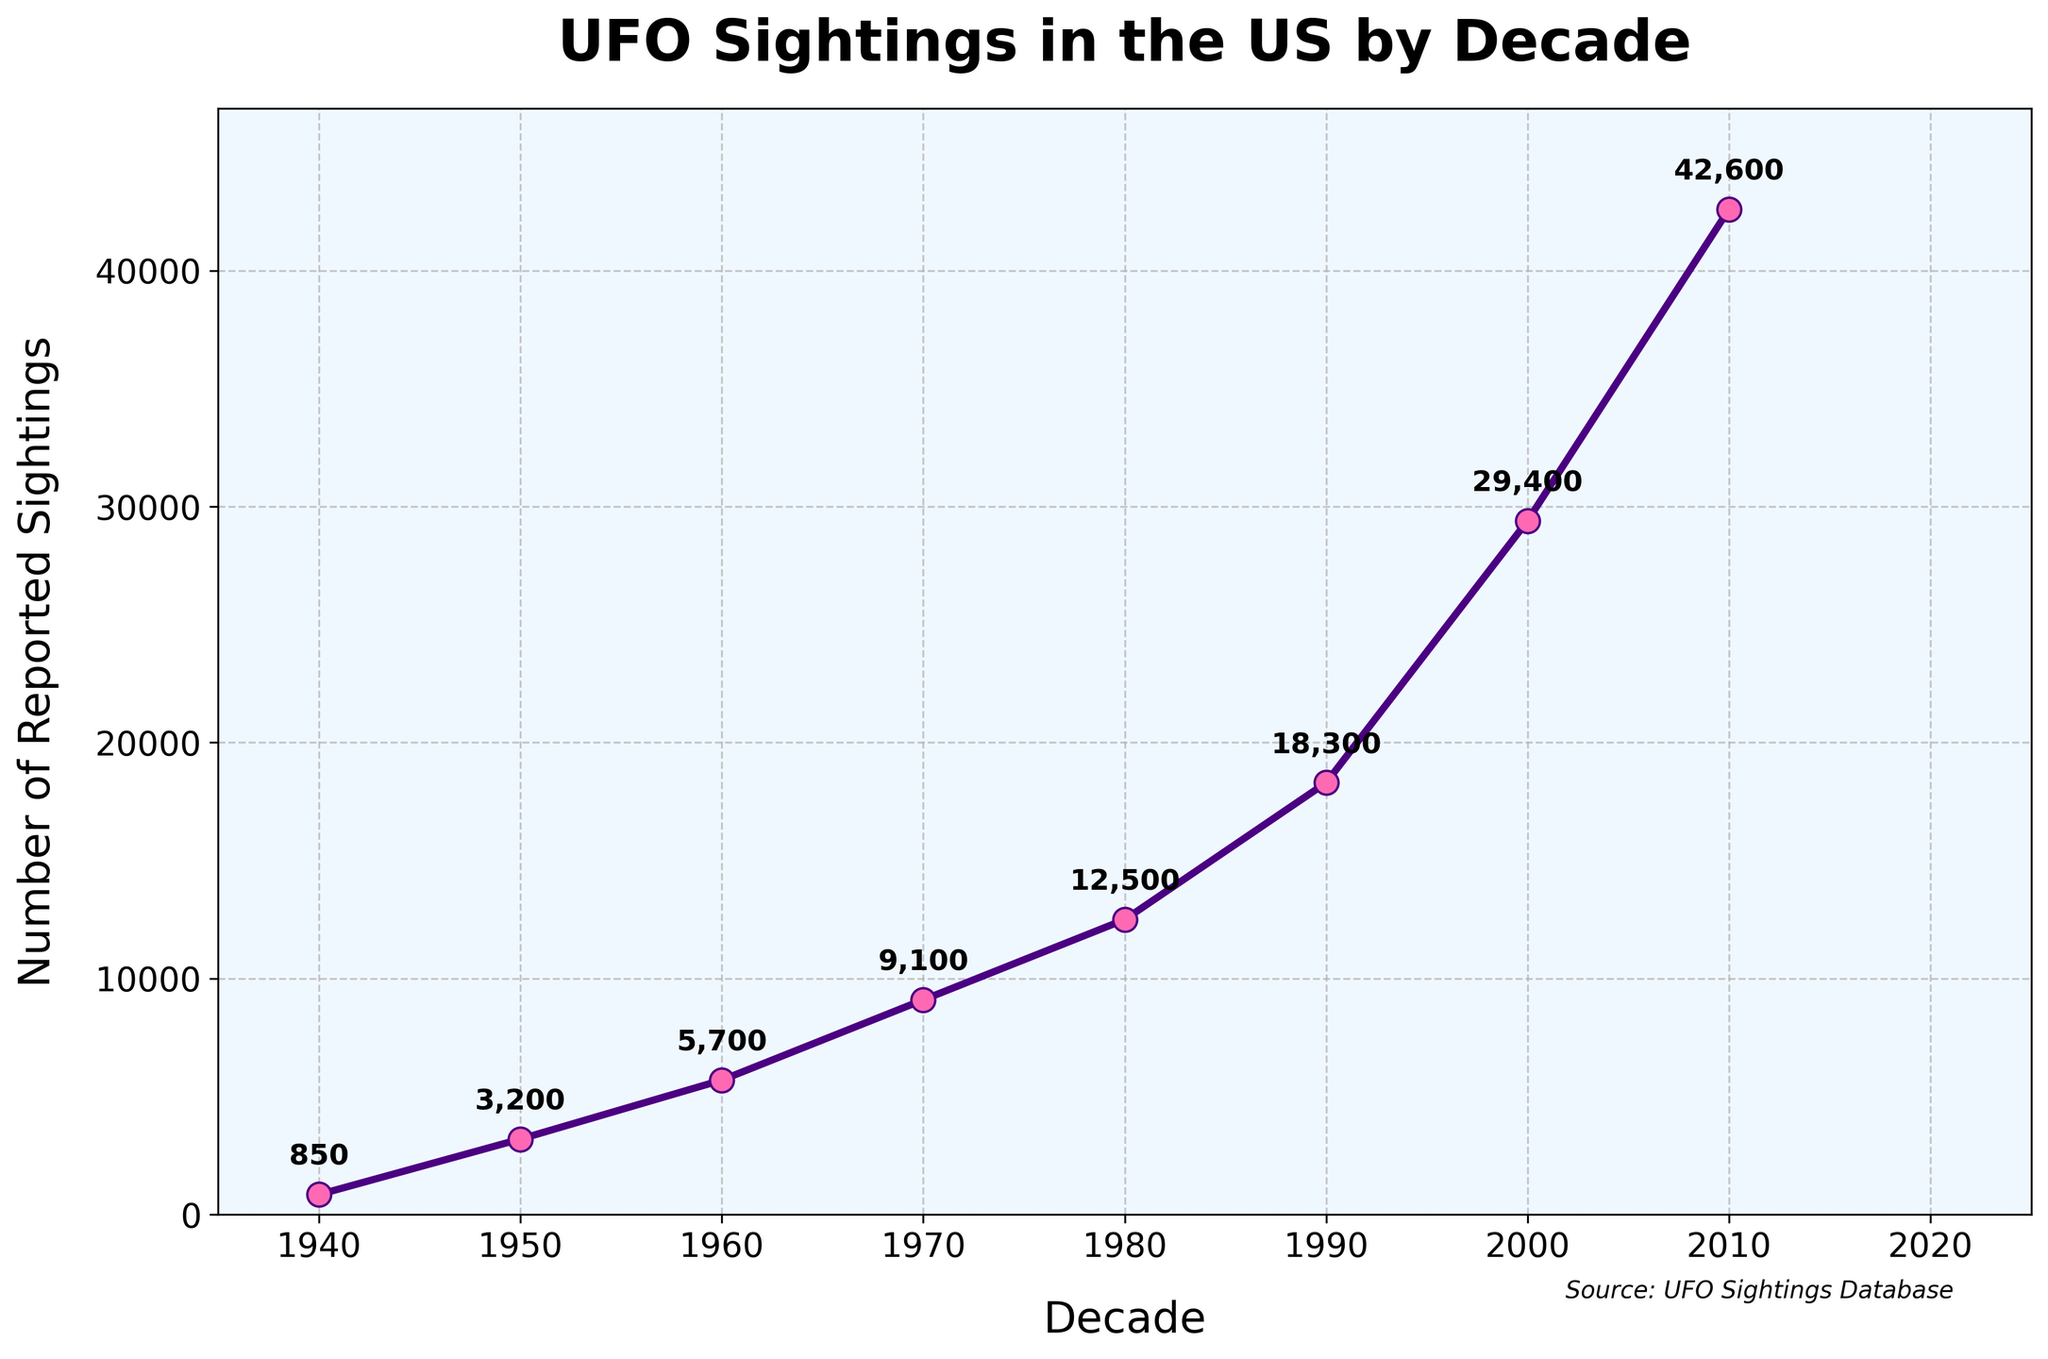What decade had the highest number of reported UFO sightings? The 2010s had the highest number as the plot shows the series peaking at this point.
Answer: 2010s What is the difference in the number of reported UFO sightings between the 1940s and the 2010s? The reported sightings in the 2010s are 42,600 and in the 1940s are 850. The difference is 42,600 - 850 = 41,750.
Answer: 41,750 Which decade saw the largest increase in the number of reported UFO sightings from the previous decade? The most significant increase on the graph appears between the 2000s and the 2010s. The increase is from 29,400 to 42,600, or 42,600 - 29,400 = 13,200.
Answer: 2010s What was the approximate average number of reported UFO sightings per decade from the 1940s to the 2010s? Sum the reported sightings for all decades: 850 + 3,200 + 5,700 + 9,100 + 12,500 + 18,300 + 29,400 + 42,600 = 121,650. Divide by the number of decades (8): 121,650 / 8 = 15,206.25.
Answer: 15,206.25 How do the reported sightings in the 1950s compare to those in the 1940s? The number of reported sightings in the 1950s is 3,200, while in the 1940s it is 850. 3,200 - 850 = 2,350 more sightings in the 1950s.
Answer: 2,350 more Between which two consecutive decades was there the smallest increase in the reported number of UFO sightings? The smallest increase is between the 1950s and 1960s, with a change from 3,200 to 5,700, which is 5,700 - 3,200 = 2,500.
Answer: 1950s to 1960s How does the trend of reported UFO sightings look from the 1940s to the 2010s? The trend shows a gradual increase in reported UFO sightings from the 1940s to the 2010s, with the most significant jump observed between the 2000s and 2010s.
Answer: Gradually increasing What is the percentage increase in reported UFO sightings from the 1980s to the 1990s? The 1980s had 12,500 sightings, and the 1990s had 18,300. The percentage increase is [(18,300 - 12,500) / 12,500] * 100% = approximately 46.4%.
Answer: 46.4% What decade marked the first notable rise in reported UFO sightings, as shown in the figure? The first notable rise is seen between the 1940s and 1950s, where the sightings shoot up from 850 to 3,200.
Answer: 1950s 